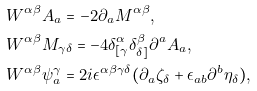<formula> <loc_0><loc_0><loc_500><loc_500>& W ^ { \alpha \beta } A _ { a } = - 2 \partial _ { a } M ^ { \alpha \beta } , \\ & W ^ { \alpha \beta } M _ { \gamma \delta } = - 4 \delta ^ { \alpha } _ { [ \gamma } \delta ^ { \beta } _ { \delta ] } \partial ^ { a } A _ { a } , \\ & W ^ { \alpha \beta } \psi _ { a } ^ { \gamma } = 2 i \epsilon ^ { \alpha \beta \gamma \delta } ( \partial _ { a } \zeta _ { \delta } + \epsilon _ { a b } \partial ^ { b } \eta _ { \delta } ) ,</formula> 